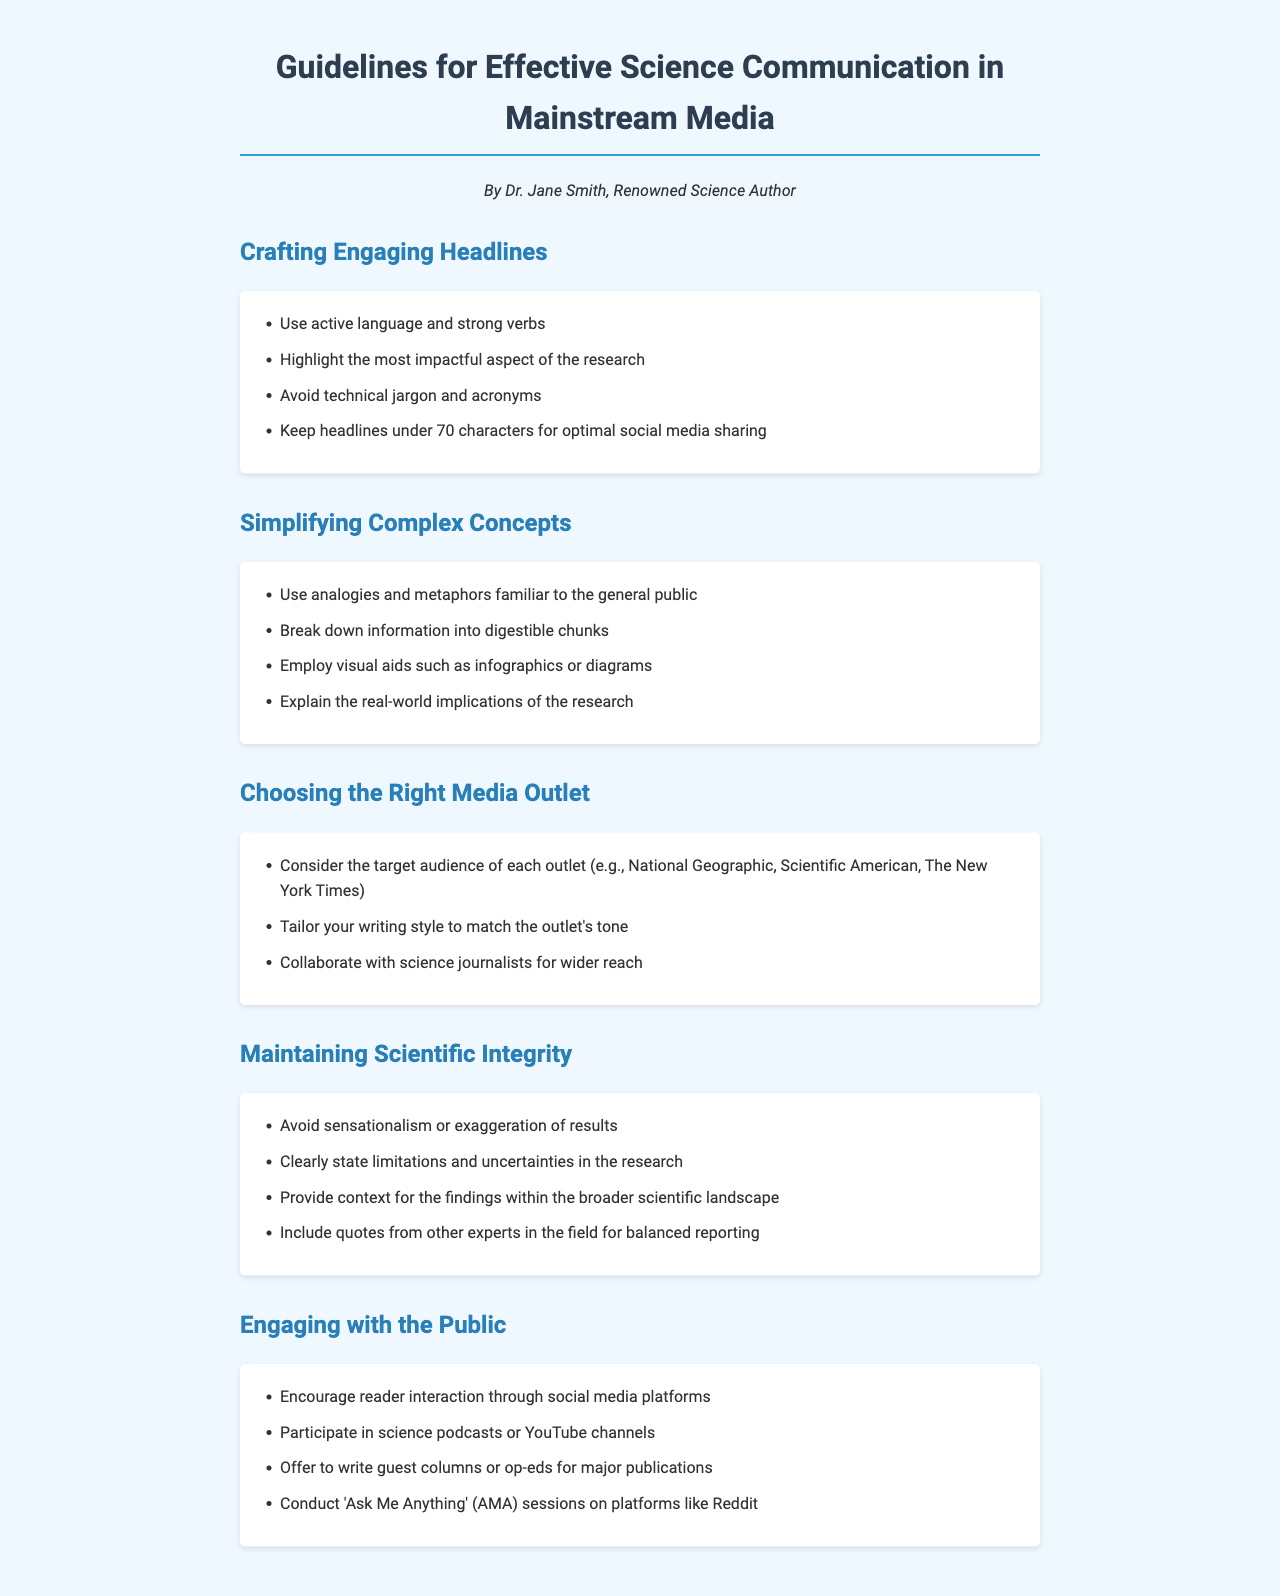What should headlines avoid? The document states that headlines should avoid technical jargon and acronyms to be more accessible.
Answer: Technical jargon and acronyms What is a recommended character limit for optimal social media sharing of headlines? The guidelines suggest keeping headlines under a specific character count for the best impact on social media.
Answer: 70 characters Which analogy technique is suggested for simplifying complex concepts? The document recommends using analogies and metaphors that are familiar to the general public to make complex concepts more relatable.
Answer: Analogies and metaphors What is one way to maintain scientific integrity in reporting? The document mentions that one way to maintain integrity is to avoid sensationalism or exaggeration of results.
Answer: Avoid sensationalism What type of media outlet should be considered for target audiences? The guidelines suggest considering various outlets, such as National Geographic or Scientific American, based on their audience demographics.
Answer: National Geographic 